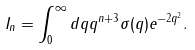Convert formula to latex. <formula><loc_0><loc_0><loc_500><loc_500>I _ { n } = \int _ { 0 } ^ { \infty } d q q ^ { n + 3 } \sigma ( q ) e ^ { - 2 q ^ { 2 } } .</formula> 